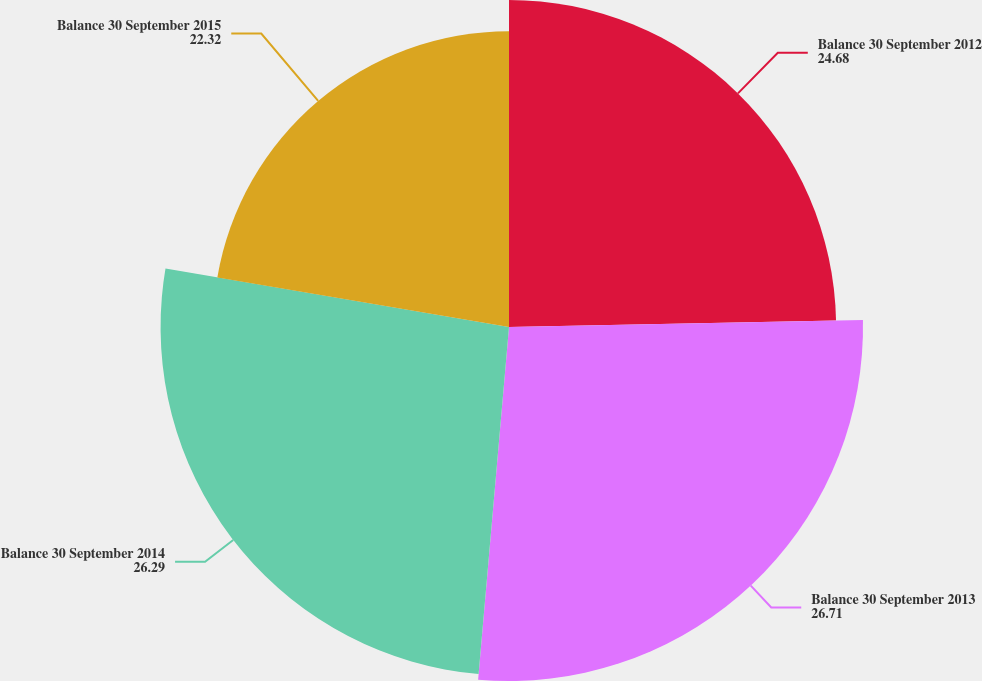Convert chart to OTSL. <chart><loc_0><loc_0><loc_500><loc_500><pie_chart><fcel>Balance 30 September 2012<fcel>Balance 30 September 2013<fcel>Balance 30 September 2014<fcel>Balance 30 September 2015<nl><fcel>24.68%<fcel>26.71%<fcel>26.29%<fcel>22.32%<nl></chart> 